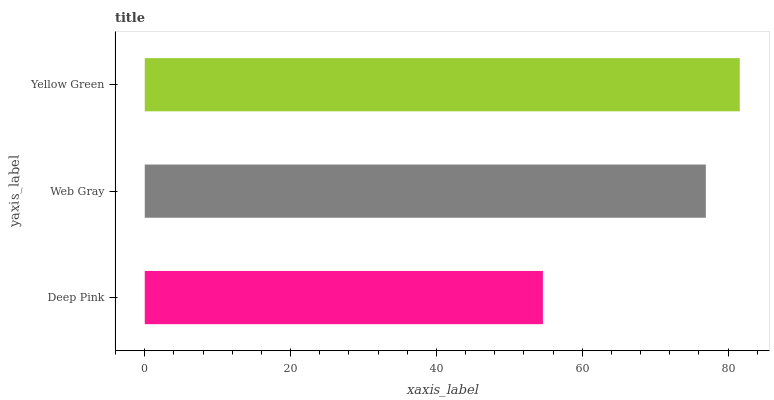Is Deep Pink the minimum?
Answer yes or no. Yes. Is Yellow Green the maximum?
Answer yes or no. Yes. Is Web Gray the minimum?
Answer yes or no. No. Is Web Gray the maximum?
Answer yes or no. No. Is Web Gray greater than Deep Pink?
Answer yes or no. Yes. Is Deep Pink less than Web Gray?
Answer yes or no. Yes. Is Deep Pink greater than Web Gray?
Answer yes or no. No. Is Web Gray less than Deep Pink?
Answer yes or no. No. Is Web Gray the high median?
Answer yes or no. Yes. Is Web Gray the low median?
Answer yes or no. Yes. Is Yellow Green the high median?
Answer yes or no. No. Is Yellow Green the low median?
Answer yes or no. No. 